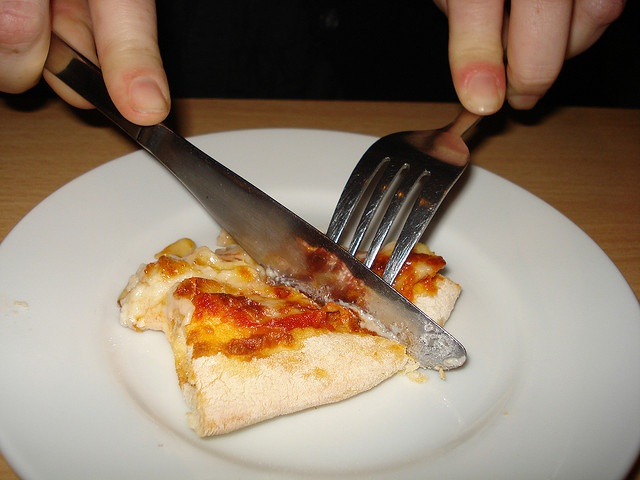Describe the objects in this image and their specific colors. I can see dining table in gray, darkgray, lightgray, tan, and maroon tones, pizza in gray, tan, orange, and red tones, people in gray, tan, brown, and maroon tones, knife in gray, black, and maroon tones, and fork in gray, black, and maroon tones in this image. 